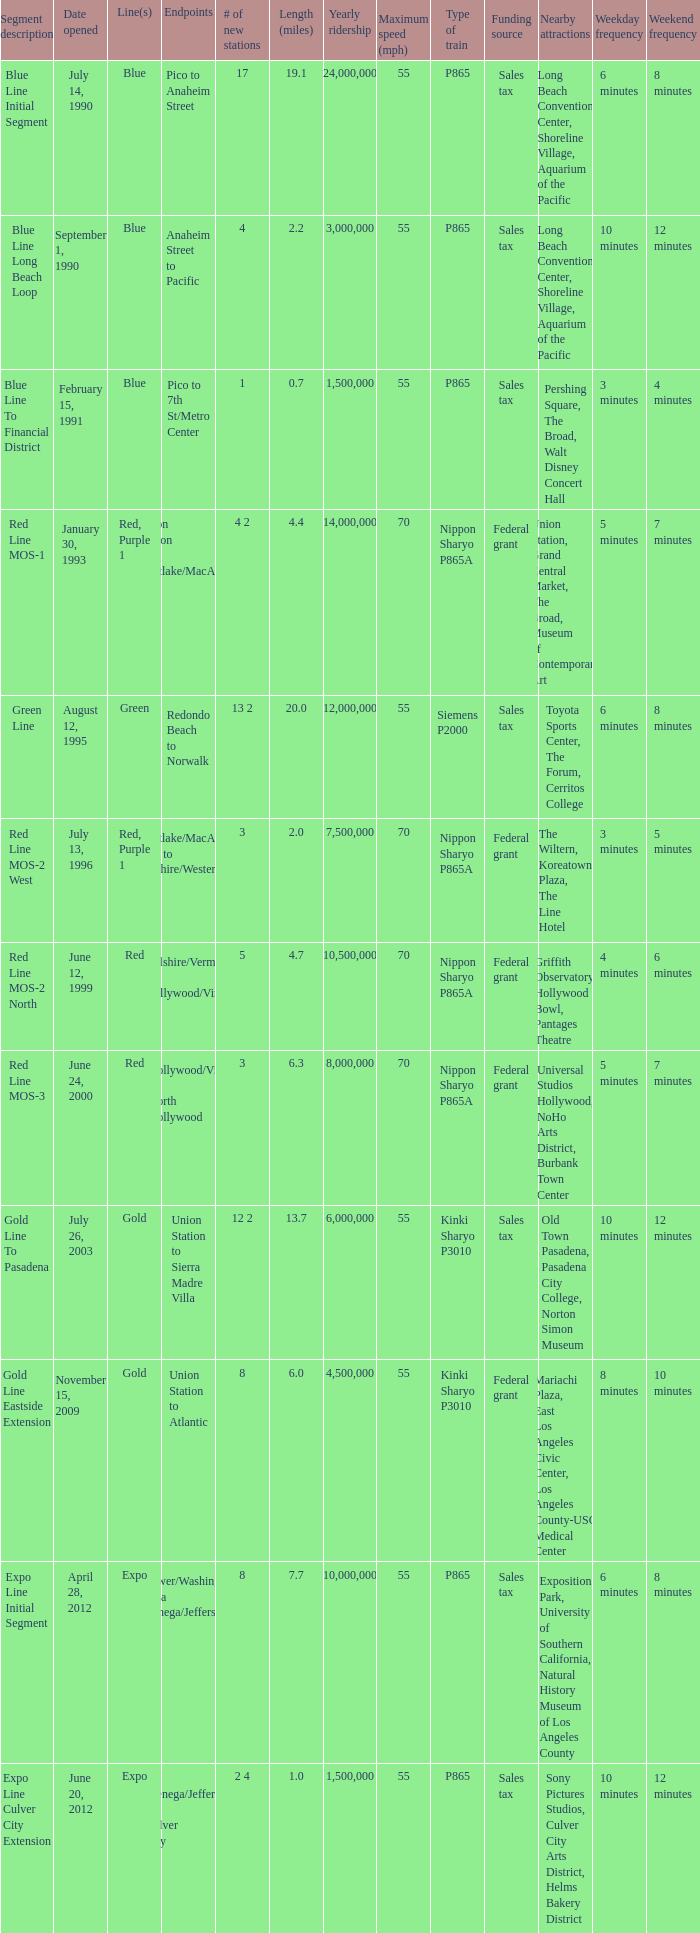What is the length  (miles) when pico to 7th st/metro center are the endpoints? 0.7. 